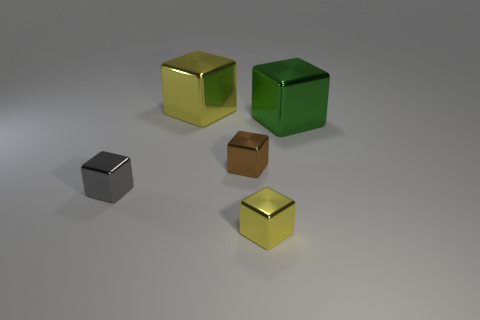Is there any other thing that has the same shape as the tiny gray object?
Provide a succinct answer. Yes. There is a brown object; what shape is it?
Offer a terse response. Cube. Do the brown shiny object behind the tiny gray block and the tiny yellow thing have the same shape?
Keep it short and to the point. Yes. Is the number of gray shiny blocks that are in front of the brown thing greater than the number of small yellow things right of the green metallic object?
Offer a terse response. Yes. What number of other objects are there of the same size as the gray metallic block?
Your answer should be very brief. 2. Is the shape of the small gray object the same as the yellow thing that is behind the large green metal cube?
Offer a very short reply. Yes. What number of shiny things are tiny brown things or tiny things?
Make the answer very short. 3. Are any small cyan matte cubes visible?
Ensure brevity in your answer.  No. Do the large green metallic thing and the large yellow metallic thing have the same shape?
Offer a terse response. Yes. What number of tiny things are either green metallic blocks or purple shiny blocks?
Provide a succinct answer. 0. 